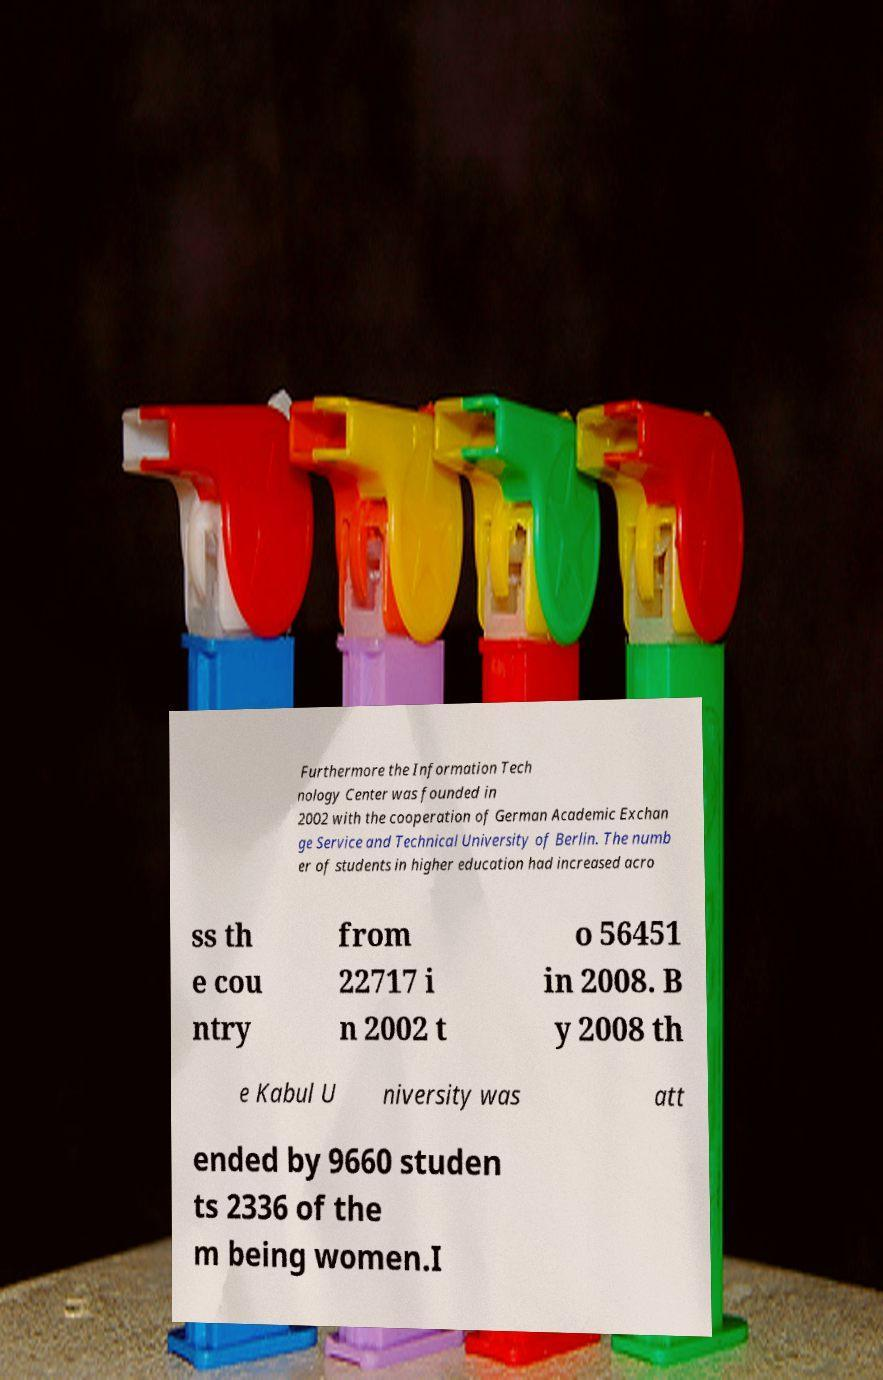Could you assist in decoding the text presented in this image and type it out clearly? Furthermore the Information Tech nology Center was founded in 2002 with the cooperation of German Academic Exchan ge Service and Technical University of Berlin. The numb er of students in higher education had increased acro ss th e cou ntry from 22717 i n 2002 t o 56451 in 2008. B y 2008 th e Kabul U niversity was att ended by 9660 studen ts 2336 of the m being women.I 